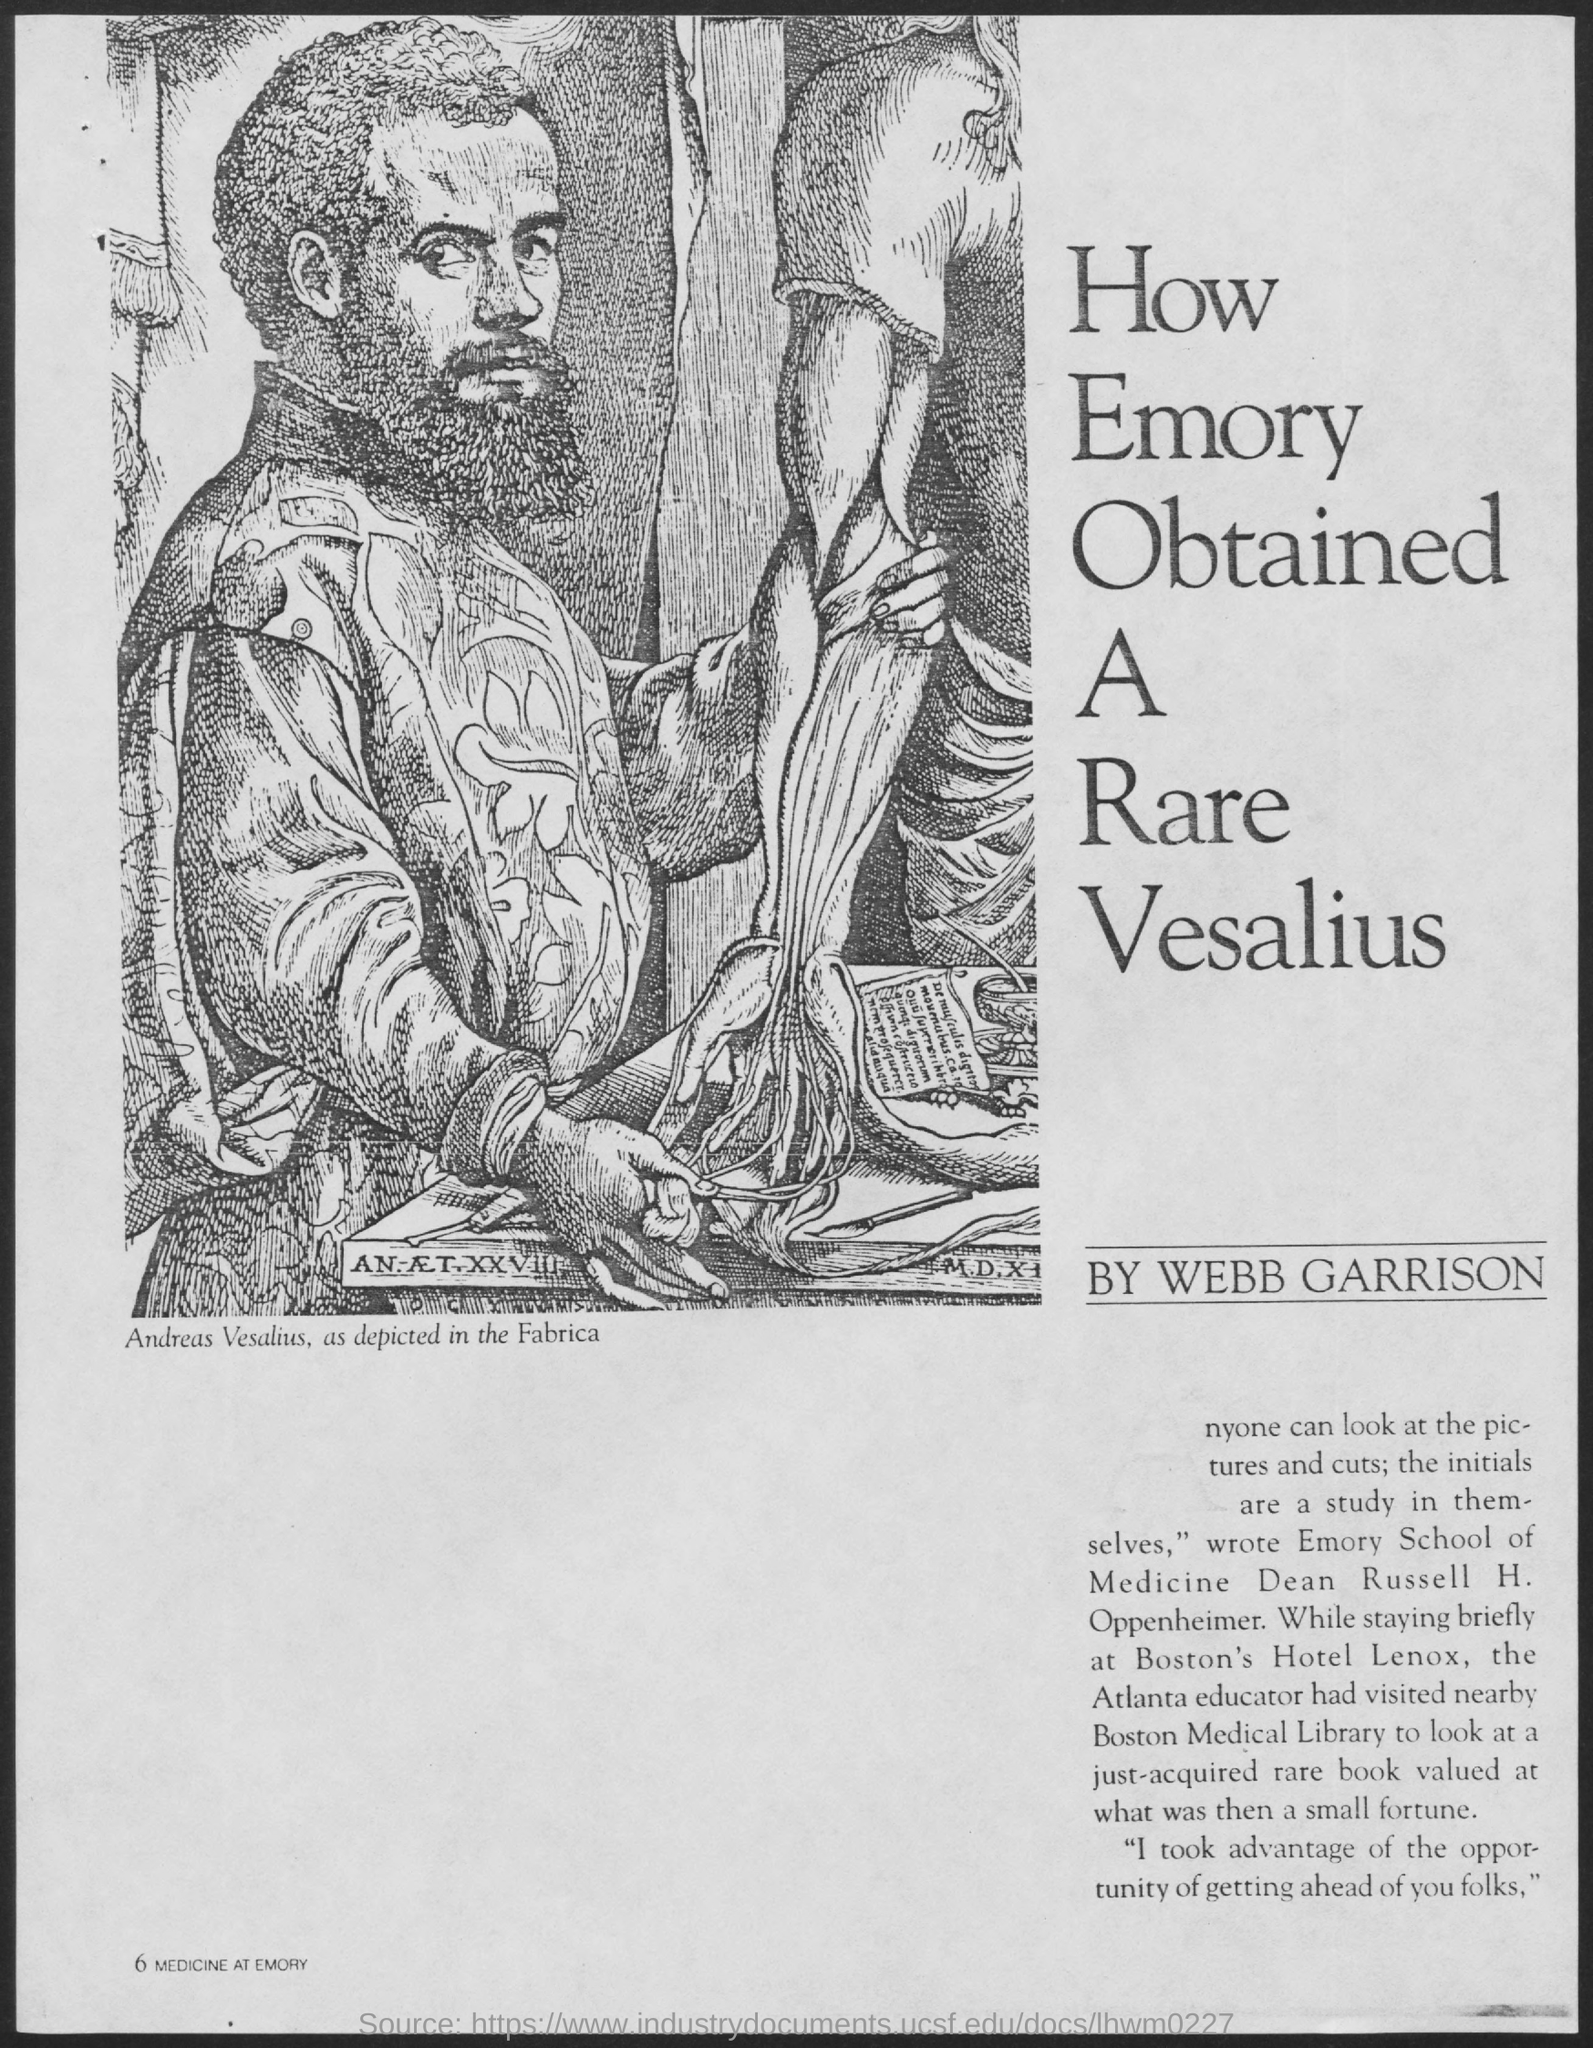Mention a couple of crucial points in this snapshot. The Dean of Emory School of Medicine was Russell H. Oppenheimer. Andreas Vesalius's picture is shown. While staying at Boston's Hotel Lenox, Russell visited the Boston Medical Library. 